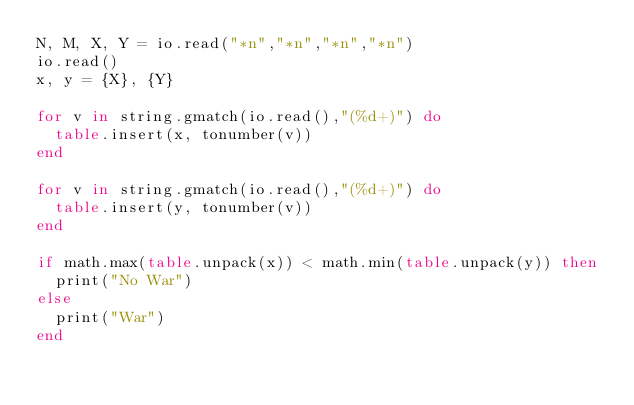<code> <loc_0><loc_0><loc_500><loc_500><_Lua_>N, M, X, Y = io.read("*n","*n","*n","*n")
io.read()
x, y = {X}, {Y}

for v in string.gmatch(io.read(),"(%d+)") do
  table.insert(x, tonumber(v))
end

for v in string.gmatch(io.read(),"(%d+)") do
  table.insert(y, tonumber(v))
end

if math.max(table.unpack(x)) < math.min(table.unpack(y)) then
  print("No War")
else
  print("War")
end</code> 